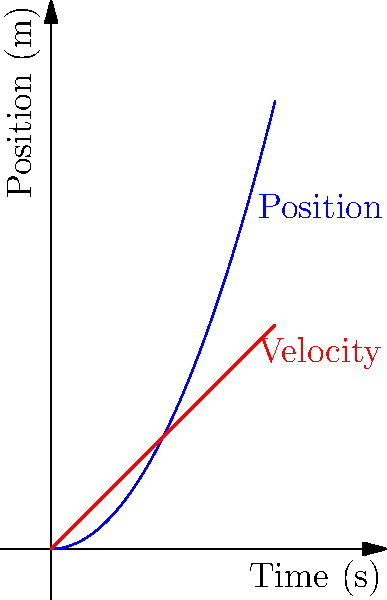During a stretching exercise, a person's arm movement is tracked. The blue curve represents the position-time graph, and the red line represents the velocity-time graph. At $t=2$ seconds, what is the instantaneous acceleration of the arm? To find the instantaneous acceleration at $t=2$ seconds, we need to follow these steps:

1) The position function is given by the blue curve: $s(t) = 0.5t^2$

2) The velocity function is the derivative of the position function:
   $v(t) = \frac{d}{dt}s(t) = t$

3) The acceleration function is the derivative of the velocity function:
   $a(t) = \frac{d}{dt}v(t) = \frac{d}{dt}t = 1$

4) The acceleration is constant and equal to 1 m/s² for all values of t.

5) Therefore, at $t=2$ seconds, the instantaneous acceleration is 1 m/s².

This constant acceleration explains why the velocity graph is a straight line with a slope of 1, and why the position graph is a parabola.
Answer: 1 m/s² 